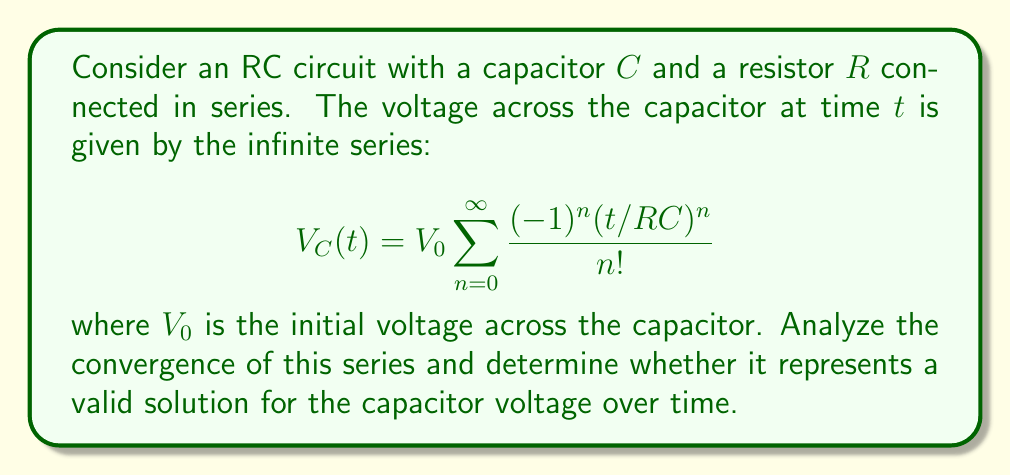Provide a solution to this math problem. To analyze the convergence of this infinite series, we'll use the ratio test:

1) First, let's define the general term of the series:

   $$a_n = \frac{(-1)^n(t/RC)^n}{n!}$$

2) Now, we'll calculate the limit of the ratio of successive terms:

   $$\lim_{n \to \infty} \left|\frac{a_{n+1}}{a_n}\right| = \lim_{n \to \infty} \left|\frac{(-1)^{n+1}(t/RC)^{n+1}/(n+1)!}{(-1)^n(t/RC)^n/n!}\right|$$

3) Simplifying:

   $$\lim_{n \to \infty} \left|\frac{t/RC}{n+1}\right| = \lim_{n \to \infty} \frac{|t/RC|}{n+1} = 0$$

4) Since the limit is 0, which is less than 1, the series converges absolutely for all finite values of $t$, $R$, and $C$.

5) Now, let's consider the physical interpretation. This series is actually the Taylor series expansion of the exponential function:

   $$V_C(t) = V_0 e^{-t/RC}$$

6) This is indeed the correct solution for the voltage across a capacitor in an RC circuit during discharge, where $RC$ is the time constant of the circuit.

7) The convergence of the series for all $t$ means that this solution is valid for all time, which aligns with our understanding of RC circuit behavior.
Answer: The infinite series converges absolutely for all finite values of $t$, $R$, and $C$. It represents a valid solution for the capacitor voltage over time, given by the closed-form expression $V_C(t) = V_0 e^{-t/RC}$. 